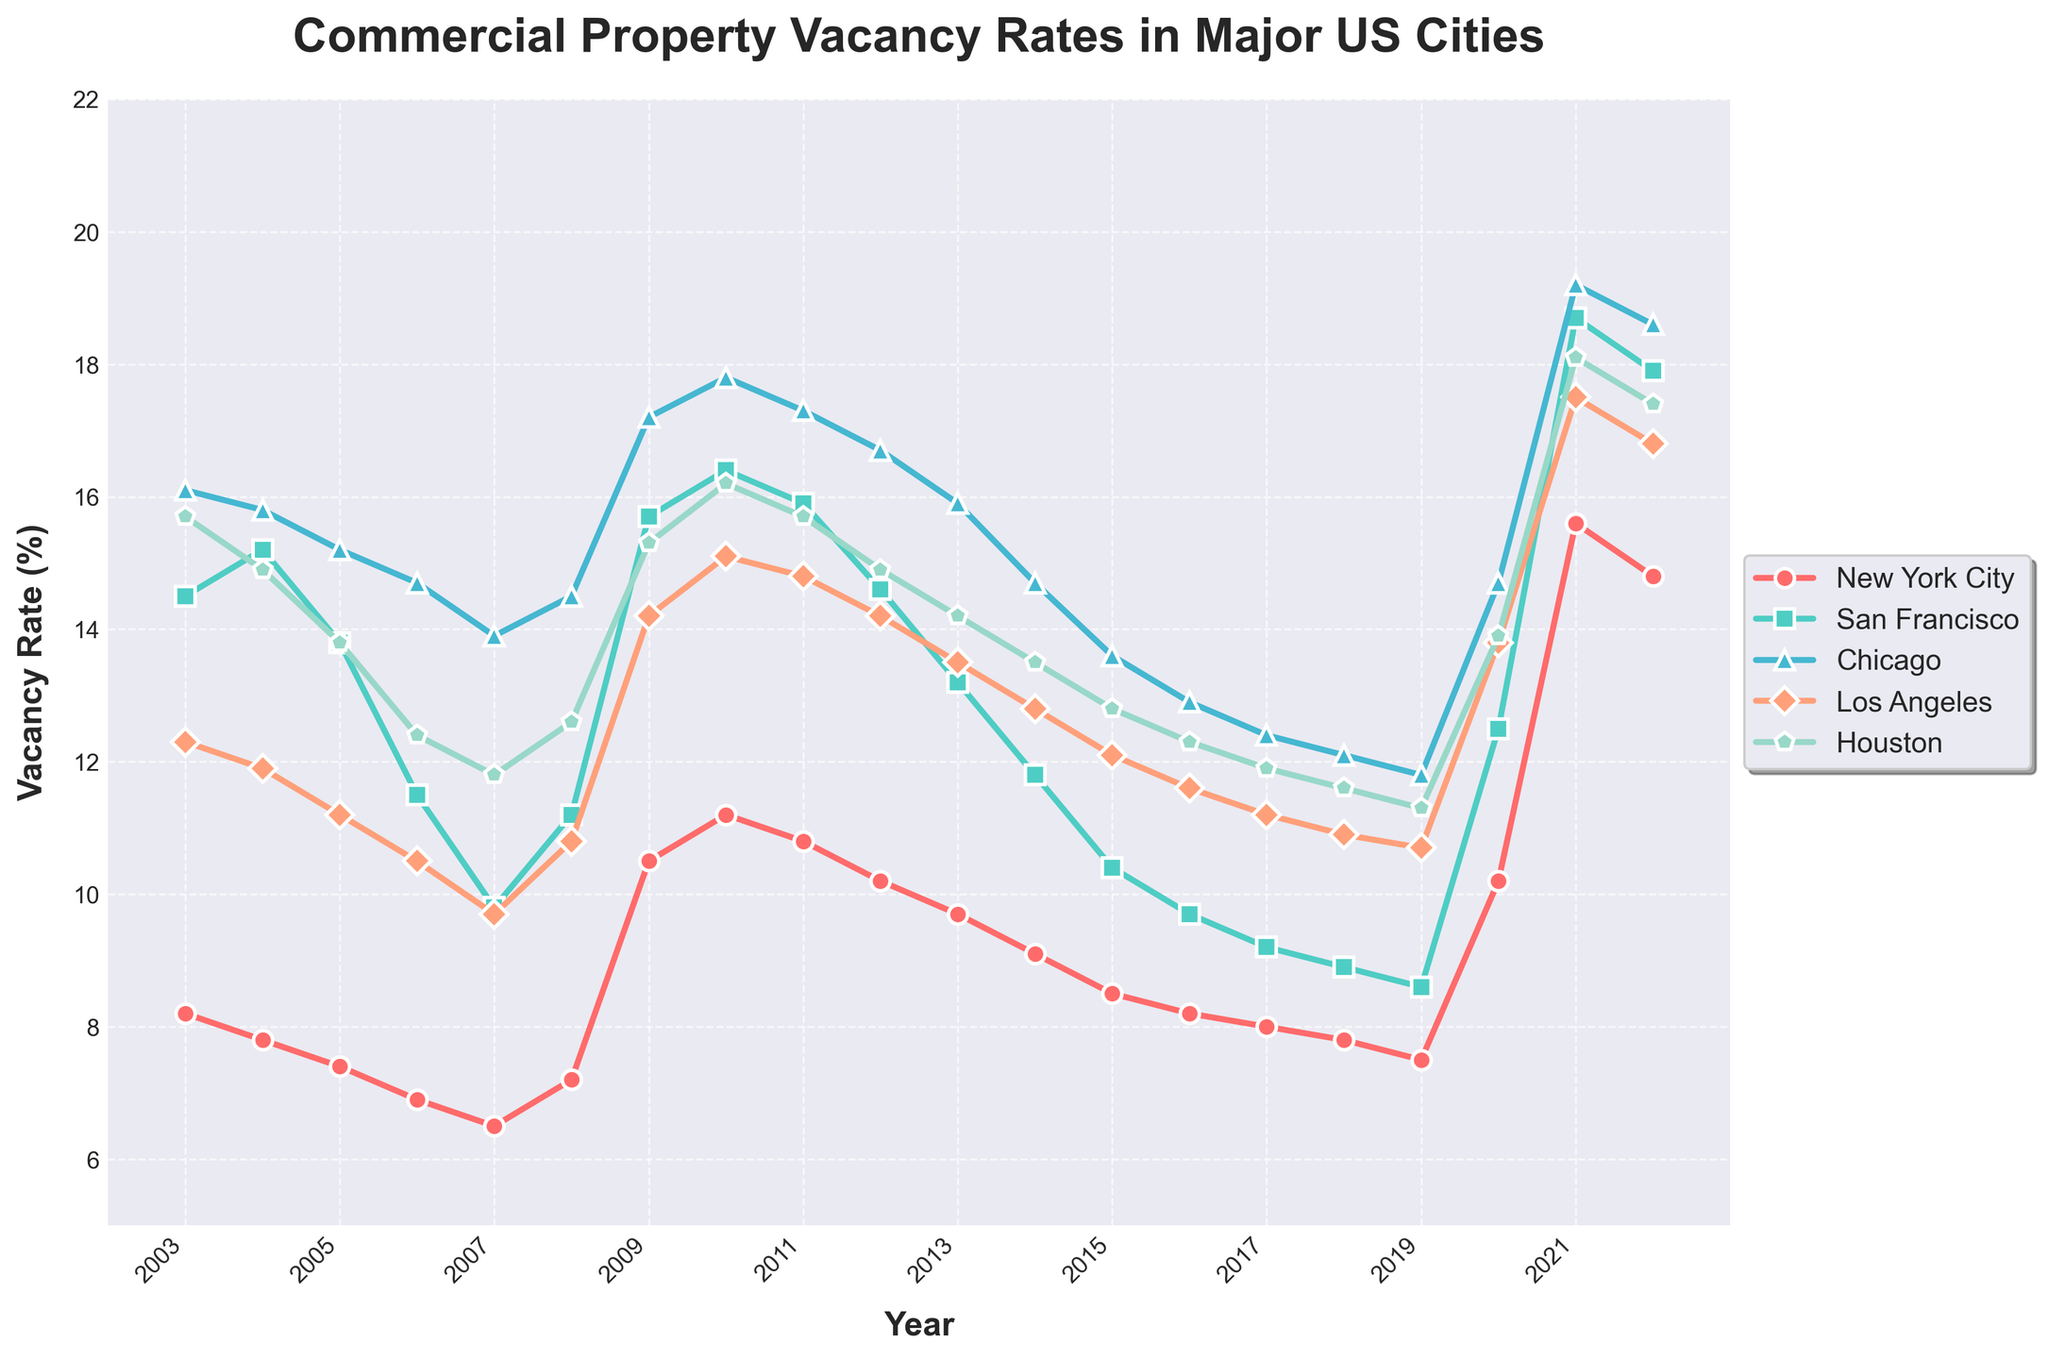What was the vacancy rate in New York City in the year 2021? Look for the year 2021 on the x-axis and find the corresponding data point for New York City, which is marked with a specific color and marker on the plot.
Answer: 15.6 Which city had the highest commercial property vacancy rate in 2022? On the plot, find the year 2022 on the x-axis and compare the vacancy rates of all cities for that year. The highest data point represents the city with the highest vacancy rate.
Answer: San Francisco Between which years did Chicago see the sharpest increase in vacancy rates? Identify the steepest upward segment of the Chicago line on the graph. Compare changes in vacancy rates year over year to determine the steepest increase.
Answer: 2020-2021 On average, how did the vacancy rate in Los Angeles change from 2008 to 2012? Calculate the average rate of change by subtracting the vacancy rate in 2008 from that in 2012, then divide by the number of years between them. The difference is (14.2 - 10.8) over 4 years.
Answer: -0.85% per year Which year shows a noticeably different trend for all cities compared to the other years? Scan the graph for a year where there is a consistent change across all city lines, either an increase or decrease, that stands out compared to the other years.
Answer: 2020 What was the range of the vacancy rates across all cities in 2009? Identify the highest and lowest data points for the year 2009 and subtract the lowest rate from the highest rate to find the range.
Answer: 7.0% How does the vacancy rate in Houston in 2006 compare to that in 2016? Locate the points for Houston in 2006 and 2016 on the plot and compare the values.
Answer: The vacancy rate is lower in 2016 Which city had the most stable vacancy rates over the 20-year period? Observe the lines representing each city and identify which city has the least fluctuation in its line trajectory over the years.
Answer: New York City What is the general trend of vacancy rates in San Francisco from 2003 to 2019? Look at the plot for San Francisco and analyze the overall direction of the line from 2003 to 2019. Determine if it is generally increasing, decreasing, or stable.
Answer: Decreasing In which year did New York City have its highest vacancy rate and what was it? Find the peak point for the New York City line on the graph and note the corresponding year and rate.
Answer: 2021, 15.6% 